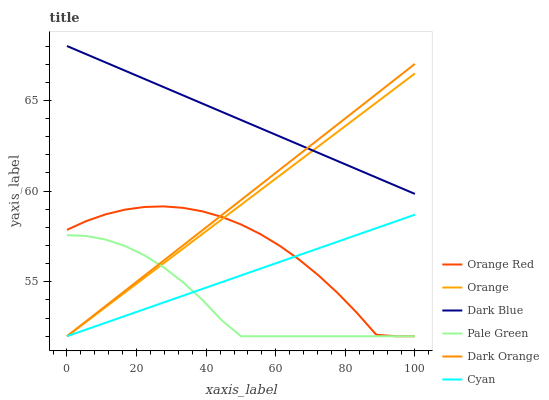Does Dark Blue have the minimum area under the curve?
Answer yes or no. No. Does Pale Green have the maximum area under the curve?
Answer yes or no. No. Is Dark Blue the smoothest?
Answer yes or no. No. Is Dark Blue the roughest?
Answer yes or no. No. Does Dark Blue have the lowest value?
Answer yes or no. No. Does Pale Green have the highest value?
Answer yes or no. No. Is Pale Green less than Dark Blue?
Answer yes or no. Yes. Is Dark Blue greater than Cyan?
Answer yes or no. Yes. Does Pale Green intersect Dark Blue?
Answer yes or no. No. 